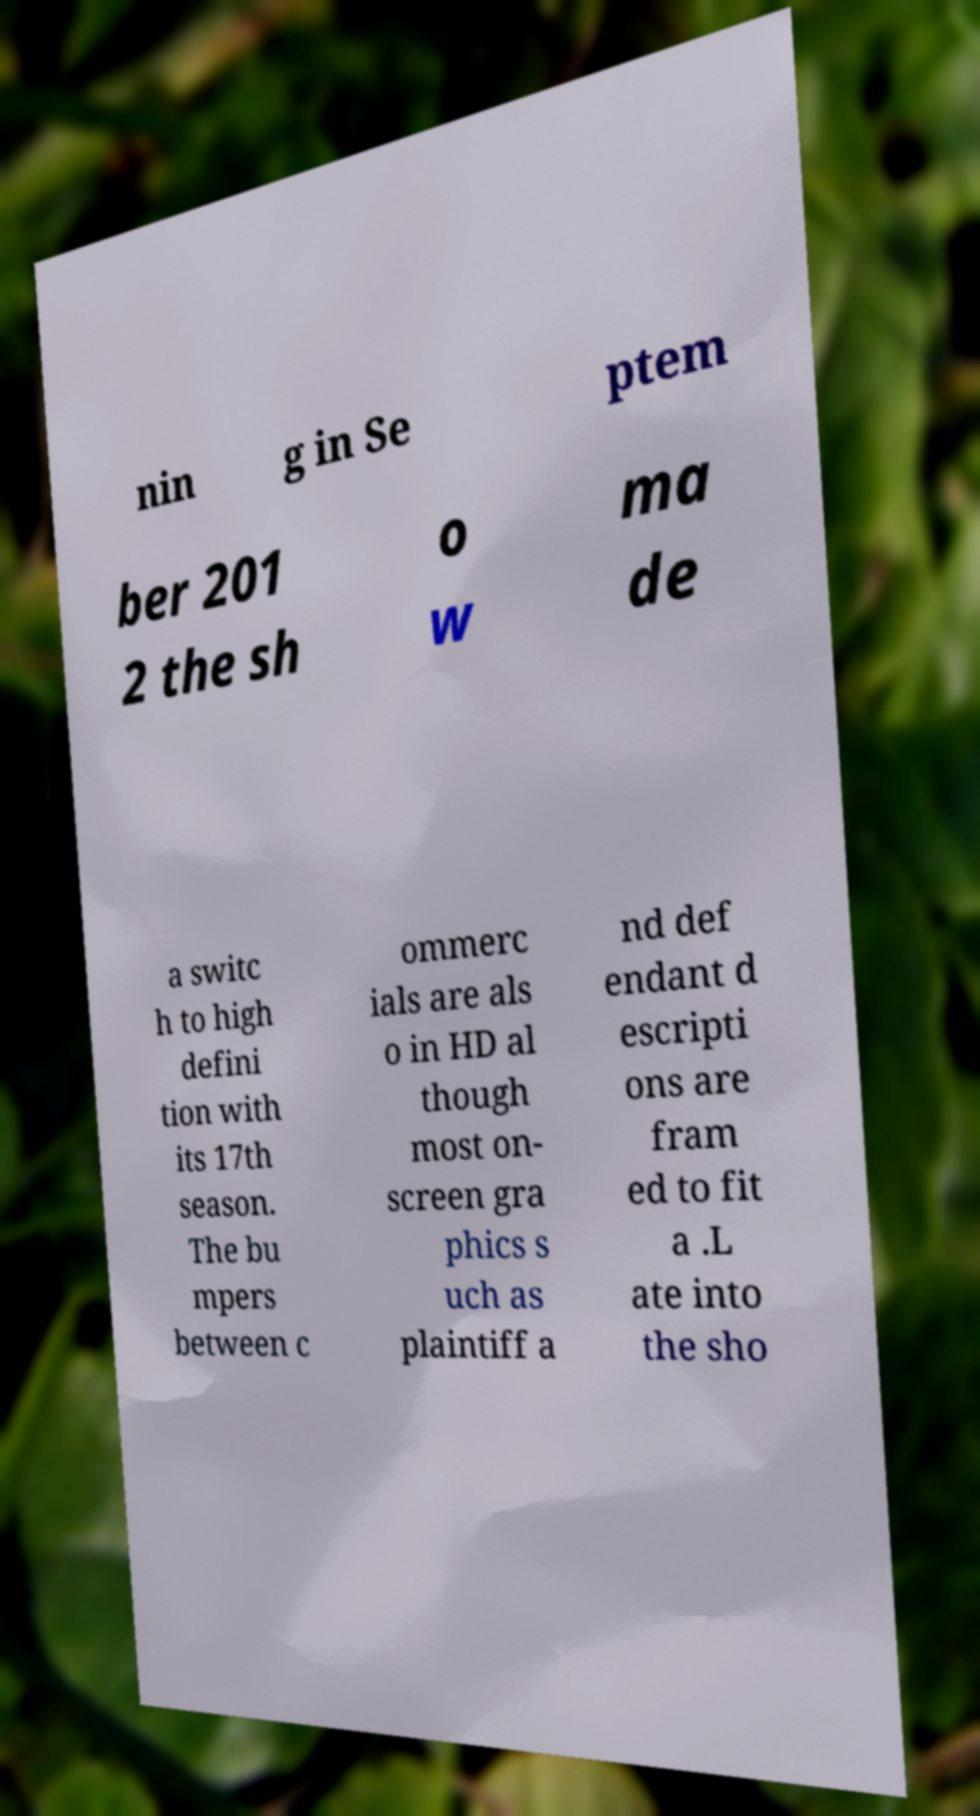Could you extract and type out the text from this image? nin g in Se ptem ber 201 2 the sh o w ma de a switc h to high defini tion with its 17th season. The bu mpers between c ommerc ials are als o in HD al though most on- screen gra phics s uch as plaintiff a nd def endant d escripti ons are fram ed to fit a .L ate into the sho 